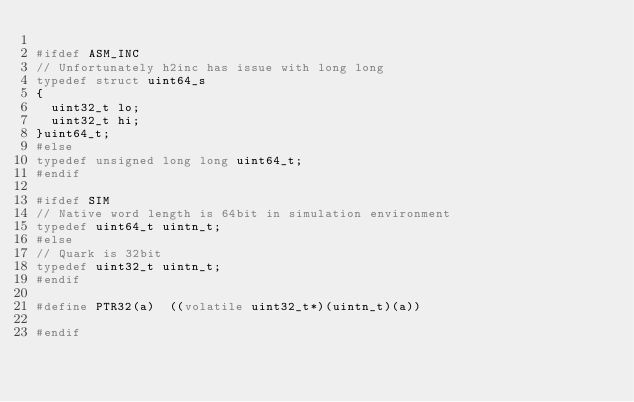Convert code to text. <code><loc_0><loc_0><loc_500><loc_500><_C_>
#ifdef ASM_INC
// Unfortunately h2inc has issue with long long
typedef struct uint64_s
{
  uint32_t lo;
  uint32_t hi;
}uint64_t;
#else
typedef unsigned long long uint64_t;
#endif

#ifdef SIM
// Native word length is 64bit in simulation environment
typedef uint64_t uintn_t;
#else
// Quark is 32bit
typedef uint32_t uintn_t;
#endif

#define PTR32(a)  ((volatile uint32_t*)(uintn_t)(a))

#endif

</code> 